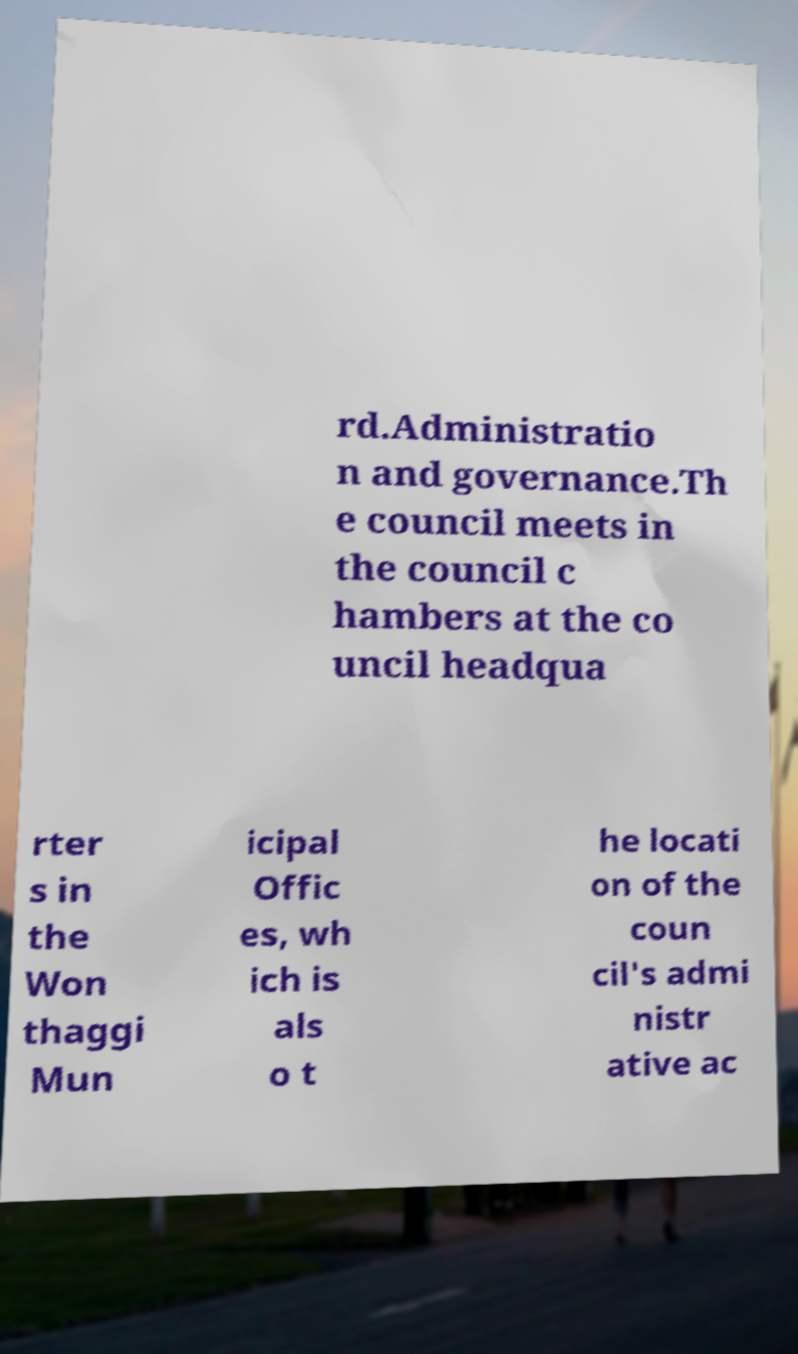There's text embedded in this image that I need extracted. Can you transcribe it verbatim? rd.Administratio n and governance.Th e council meets in the council c hambers at the co uncil headqua rter s in the Won thaggi Mun icipal Offic es, wh ich is als o t he locati on of the coun cil's admi nistr ative ac 